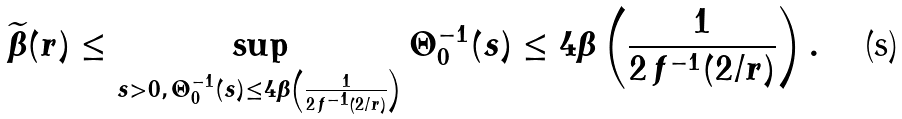<formula> <loc_0><loc_0><loc_500><loc_500>\widetilde { \beta } ( r ) \leq \sup _ { s > 0 , \, \Theta _ { 0 } ^ { - 1 } ( s ) \leq 4 \beta \left ( \frac { 1 } { 2 \, f ^ { - 1 } ( 2 / r ) } \right ) } \Theta _ { 0 } ^ { - 1 } ( s ) \leq 4 \beta \left ( \frac { 1 } { 2 \, f ^ { - 1 } ( 2 / r ) } \right ) .</formula> 